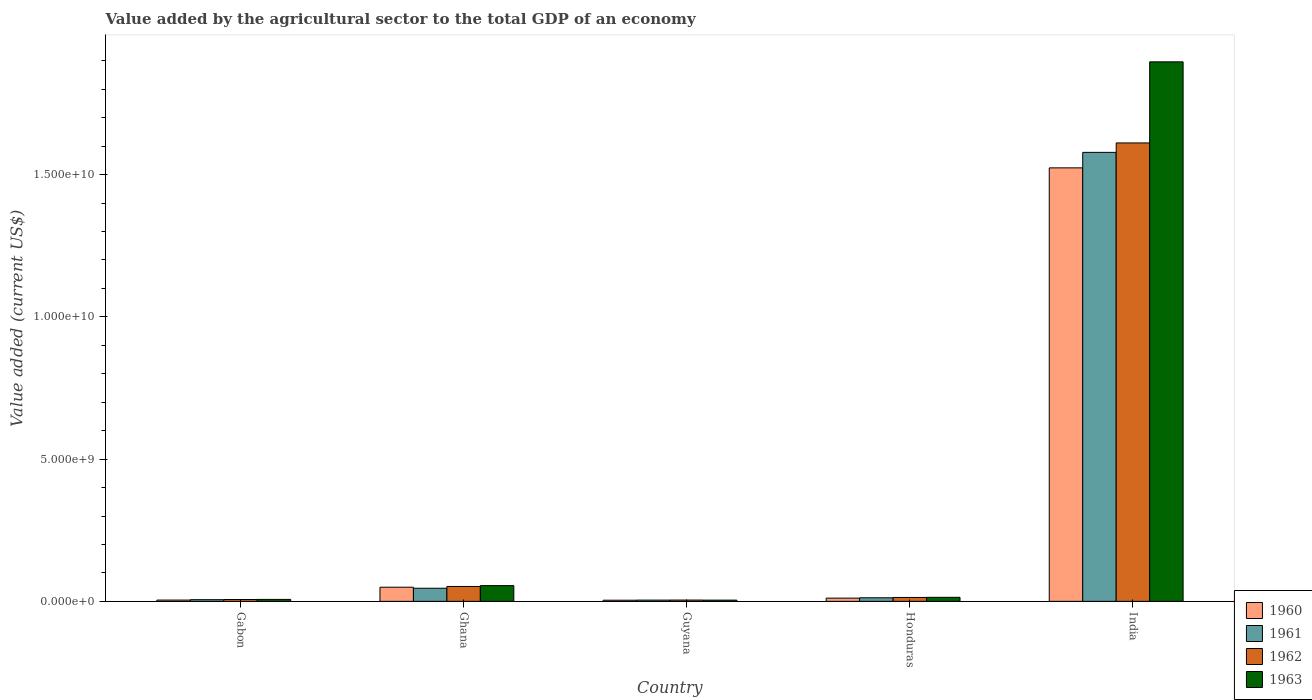How many groups of bars are there?
Offer a very short reply. 5. Are the number of bars on each tick of the X-axis equal?
Provide a short and direct response. Yes. How many bars are there on the 4th tick from the left?
Keep it short and to the point. 4. In how many cases, is the number of bars for a given country not equal to the number of legend labels?
Offer a terse response. 0. What is the value added by the agricultural sector to the total GDP in 1962 in Ghana?
Provide a succinct answer. 5.24e+08. Across all countries, what is the maximum value added by the agricultural sector to the total GDP in 1963?
Make the answer very short. 1.90e+1. Across all countries, what is the minimum value added by the agricultural sector to the total GDP in 1962?
Ensure brevity in your answer.  4.57e+07. In which country was the value added by the agricultural sector to the total GDP in 1962 maximum?
Make the answer very short. India. In which country was the value added by the agricultural sector to the total GDP in 1963 minimum?
Make the answer very short. Guyana. What is the total value added by the agricultural sector to the total GDP in 1962 in the graph?
Provide a short and direct response. 1.69e+1. What is the difference between the value added by the agricultural sector to the total GDP in 1961 in Ghana and that in Honduras?
Ensure brevity in your answer.  3.35e+08. What is the difference between the value added by the agricultural sector to the total GDP in 1961 in Ghana and the value added by the agricultural sector to the total GDP in 1962 in Honduras?
Provide a succinct answer. 3.24e+08. What is the average value added by the agricultural sector to the total GDP in 1963 per country?
Give a very brief answer. 3.95e+09. What is the difference between the value added by the agricultural sector to the total GDP of/in 1962 and value added by the agricultural sector to the total GDP of/in 1963 in India?
Keep it short and to the point. -2.85e+09. In how many countries, is the value added by the agricultural sector to the total GDP in 1961 greater than 16000000000 US$?
Ensure brevity in your answer.  0. What is the ratio of the value added by the agricultural sector to the total GDP in 1960 in Ghana to that in India?
Give a very brief answer. 0.03. What is the difference between the highest and the second highest value added by the agricultural sector to the total GDP in 1961?
Provide a short and direct response. -1.57e+1. What is the difference between the highest and the lowest value added by the agricultural sector to the total GDP in 1960?
Make the answer very short. 1.52e+1. Is the sum of the value added by the agricultural sector to the total GDP in 1961 in Gabon and Honduras greater than the maximum value added by the agricultural sector to the total GDP in 1960 across all countries?
Offer a very short reply. No. Is it the case that in every country, the sum of the value added by the agricultural sector to the total GDP in 1963 and value added by the agricultural sector to the total GDP in 1962 is greater than the sum of value added by the agricultural sector to the total GDP in 1960 and value added by the agricultural sector to the total GDP in 1961?
Offer a very short reply. No. Is it the case that in every country, the sum of the value added by the agricultural sector to the total GDP in 1963 and value added by the agricultural sector to the total GDP in 1960 is greater than the value added by the agricultural sector to the total GDP in 1961?
Keep it short and to the point. Yes. How many countries are there in the graph?
Keep it short and to the point. 5. What is the difference between two consecutive major ticks on the Y-axis?
Your answer should be very brief. 5.00e+09. Are the values on the major ticks of Y-axis written in scientific E-notation?
Make the answer very short. Yes. Does the graph contain any zero values?
Your answer should be compact. No. Does the graph contain grids?
Make the answer very short. No. Where does the legend appear in the graph?
Make the answer very short. Bottom right. What is the title of the graph?
Provide a short and direct response. Value added by the agricultural sector to the total GDP of an economy. Does "1973" appear as one of the legend labels in the graph?
Provide a succinct answer. No. What is the label or title of the X-axis?
Offer a very short reply. Country. What is the label or title of the Y-axis?
Keep it short and to the point. Value added (current US$). What is the Value added (current US$) in 1960 in Gabon?
Make the answer very short. 4.55e+07. What is the Value added (current US$) of 1961 in Gabon?
Offer a very short reply. 5.90e+07. What is the Value added (current US$) in 1962 in Gabon?
Give a very brief answer. 6.56e+07. What is the Value added (current US$) of 1963 in Gabon?
Your answer should be very brief. 6.81e+07. What is the Value added (current US$) of 1960 in Ghana?
Your answer should be very brief. 4.97e+08. What is the Value added (current US$) in 1961 in Ghana?
Provide a short and direct response. 4.61e+08. What is the Value added (current US$) in 1962 in Ghana?
Keep it short and to the point. 5.24e+08. What is the Value added (current US$) in 1963 in Ghana?
Keep it short and to the point. 5.53e+08. What is the Value added (current US$) in 1960 in Guyana?
Give a very brief answer. 4.01e+07. What is the Value added (current US$) in 1961 in Guyana?
Your response must be concise. 4.43e+07. What is the Value added (current US$) in 1962 in Guyana?
Ensure brevity in your answer.  4.57e+07. What is the Value added (current US$) of 1963 in Guyana?
Your answer should be compact. 4.30e+07. What is the Value added (current US$) in 1960 in Honduras?
Offer a very short reply. 1.14e+08. What is the Value added (current US$) of 1961 in Honduras?
Provide a succinct answer. 1.26e+08. What is the Value added (current US$) of 1962 in Honduras?
Your answer should be very brief. 1.37e+08. What is the Value added (current US$) in 1963 in Honduras?
Give a very brief answer. 1.41e+08. What is the Value added (current US$) in 1960 in India?
Provide a short and direct response. 1.52e+1. What is the Value added (current US$) in 1961 in India?
Ensure brevity in your answer.  1.58e+1. What is the Value added (current US$) in 1962 in India?
Offer a very short reply. 1.61e+1. What is the Value added (current US$) of 1963 in India?
Your answer should be very brief. 1.90e+1. Across all countries, what is the maximum Value added (current US$) of 1960?
Your response must be concise. 1.52e+1. Across all countries, what is the maximum Value added (current US$) of 1961?
Your answer should be very brief. 1.58e+1. Across all countries, what is the maximum Value added (current US$) of 1962?
Provide a short and direct response. 1.61e+1. Across all countries, what is the maximum Value added (current US$) of 1963?
Your answer should be very brief. 1.90e+1. Across all countries, what is the minimum Value added (current US$) in 1960?
Keep it short and to the point. 4.01e+07. Across all countries, what is the minimum Value added (current US$) of 1961?
Your response must be concise. 4.43e+07. Across all countries, what is the minimum Value added (current US$) in 1962?
Provide a short and direct response. 4.57e+07. Across all countries, what is the minimum Value added (current US$) of 1963?
Keep it short and to the point. 4.30e+07. What is the total Value added (current US$) in 1960 in the graph?
Offer a terse response. 1.59e+1. What is the total Value added (current US$) in 1961 in the graph?
Make the answer very short. 1.65e+1. What is the total Value added (current US$) in 1962 in the graph?
Offer a terse response. 1.69e+1. What is the total Value added (current US$) in 1963 in the graph?
Your answer should be very brief. 1.98e+1. What is the difference between the Value added (current US$) in 1960 in Gabon and that in Ghana?
Your answer should be compact. -4.52e+08. What is the difference between the Value added (current US$) of 1961 in Gabon and that in Ghana?
Keep it short and to the point. -4.02e+08. What is the difference between the Value added (current US$) in 1962 in Gabon and that in Ghana?
Provide a short and direct response. -4.58e+08. What is the difference between the Value added (current US$) of 1963 in Gabon and that in Ghana?
Your response must be concise. -4.85e+08. What is the difference between the Value added (current US$) in 1960 in Gabon and that in Guyana?
Keep it short and to the point. 5.40e+06. What is the difference between the Value added (current US$) of 1961 in Gabon and that in Guyana?
Provide a succinct answer. 1.47e+07. What is the difference between the Value added (current US$) of 1962 in Gabon and that in Guyana?
Provide a succinct answer. 1.99e+07. What is the difference between the Value added (current US$) of 1963 in Gabon and that in Guyana?
Make the answer very short. 2.51e+07. What is the difference between the Value added (current US$) of 1960 in Gabon and that in Honduras?
Your response must be concise. -6.80e+07. What is the difference between the Value added (current US$) in 1961 in Gabon and that in Honduras?
Your answer should be very brief. -6.66e+07. What is the difference between the Value added (current US$) in 1962 in Gabon and that in Honduras?
Your answer should be compact. -7.17e+07. What is the difference between the Value added (current US$) of 1963 in Gabon and that in Honduras?
Make the answer very short. -7.30e+07. What is the difference between the Value added (current US$) in 1960 in Gabon and that in India?
Give a very brief answer. -1.52e+1. What is the difference between the Value added (current US$) in 1961 in Gabon and that in India?
Provide a short and direct response. -1.57e+1. What is the difference between the Value added (current US$) in 1962 in Gabon and that in India?
Keep it short and to the point. -1.60e+1. What is the difference between the Value added (current US$) of 1963 in Gabon and that in India?
Your response must be concise. -1.89e+1. What is the difference between the Value added (current US$) in 1960 in Ghana and that in Guyana?
Give a very brief answer. 4.57e+08. What is the difference between the Value added (current US$) in 1961 in Ghana and that in Guyana?
Offer a terse response. 4.17e+08. What is the difference between the Value added (current US$) in 1962 in Ghana and that in Guyana?
Provide a succinct answer. 4.78e+08. What is the difference between the Value added (current US$) in 1963 in Ghana and that in Guyana?
Your response must be concise. 5.10e+08. What is the difference between the Value added (current US$) of 1960 in Ghana and that in Honduras?
Give a very brief answer. 3.84e+08. What is the difference between the Value added (current US$) in 1961 in Ghana and that in Honduras?
Offer a terse response. 3.35e+08. What is the difference between the Value added (current US$) in 1962 in Ghana and that in Honduras?
Your answer should be compact. 3.87e+08. What is the difference between the Value added (current US$) in 1963 in Ghana and that in Honduras?
Give a very brief answer. 4.12e+08. What is the difference between the Value added (current US$) of 1960 in Ghana and that in India?
Offer a very short reply. -1.47e+1. What is the difference between the Value added (current US$) of 1961 in Ghana and that in India?
Ensure brevity in your answer.  -1.53e+1. What is the difference between the Value added (current US$) in 1962 in Ghana and that in India?
Provide a short and direct response. -1.56e+1. What is the difference between the Value added (current US$) in 1963 in Ghana and that in India?
Offer a terse response. -1.84e+1. What is the difference between the Value added (current US$) of 1960 in Guyana and that in Honduras?
Ensure brevity in your answer.  -7.34e+07. What is the difference between the Value added (current US$) in 1961 in Guyana and that in Honduras?
Offer a terse response. -8.13e+07. What is the difference between the Value added (current US$) in 1962 in Guyana and that in Honduras?
Ensure brevity in your answer.  -9.15e+07. What is the difference between the Value added (current US$) in 1963 in Guyana and that in Honduras?
Ensure brevity in your answer.  -9.82e+07. What is the difference between the Value added (current US$) of 1960 in Guyana and that in India?
Keep it short and to the point. -1.52e+1. What is the difference between the Value added (current US$) in 1961 in Guyana and that in India?
Provide a succinct answer. -1.57e+1. What is the difference between the Value added (current US$) of 1962 in Guyana and that in India?
Ensure brevity in your answer.  -1.61e+1. What is the difference between the Value added (current US$) in 1963 in Guyana and that in India?
Your answer should be very brief. -1.89e+1. What is the difference between the Value added (current US$) in 1960 in Honduras and that in India?
Offer a very short reply. -1.51e+1. What is the difference between the Value added (current US$) in 1961 in Honduras and that in India?
Your answer should be compact. -1.57e+1. What is the difference between the Value added (current US$) of 1962 in Honduras and that in India?
Provide a short and direct response. -1.60e+1. What is the difference between the Value added (current US$) of 1963 in Honduras and that in India?
Your answer should be very brief. -1.88e+1. What is the difference between the Value added (current US$) in 1960 in Gabon and the Value added (current US$) in 1961 in Ghana?
Your response must be concise. -4.15e+08. What is the difference between the Value added (current US$) of 1960 in Gabon and the Value added (current US$) of 1962 in Ghana?
Provide a short and direct response. -4.78e+08. What is the difference between the Value added (current US$) of 1960 in Gabon and the Value added (current US$) of 1963 in Ghana?
Offer a terse response. -5.08e+08. What is the difference between the Value added (current US$) of 1961 in Gabon and the Value added (current US$) of 1962 in Ghana?
Offer a terse response. -4.65e+08. What is the difference between the Value added (current US$) in 1961 in Gabon and the Value added (current US$) in 1963 in Ghana?
Give a very brief answer. -4.94e+08. What is the difference between the Value added (current US$) in 1962 in Gabon and the Value added (current US$) in 1963 in Ghana?
Offer a terse response. -4.88e+08. What is the difference between the Value added (current US$) in 1960 in Gabon and the Value added (current US$) in 1961 in Guyana?
Make the answer very short. 1.20e+06. What is the difference between the Value added (current US$) of 1960 in Gabon and the Value added (current US$) of 1962 in Guyana?
Ensure brevity in your answer.  -1.99e+05. What is the difference between the Value added (current US$) in 1960 in Gabon and the Value added (current US$) in 1963 in Guyana?
Make the answer very short. 2.54e+06. What is the difference between the Value added (current US$) in 1961 in Gabon and the Value added (current US$) in 1962 in Guyana?
Make the answer very short. 1.33e+07. What is the difference between the Value added (current US$) of 1961 in Gabon and the Value added (current US$) of 1963 in Guyana?
Give a very brief answer. 1.60e+07. What is the difference between the Value added (current US$) of 1962 in Gabon and the Value added (current US$) of 1963 in Guyana?
Give a very brief answer. 2.26e+07. What is the difference between the Value added (current US$) in 1960 in Gabon and the Value added (current US$) in 1961 in Honduras?
Keep it short and to the point. -8.01e+07. What is the difference between the Value added (current US$) in 1960 in Gabon and the Value added (current US$) in 1962 in Honduras?
Offer a very short reply. -9.17e+07. What is the difference between the Value added (current US$) of 1960 in Gabon and the Value added (current US$) of 1963 in Honduras?
Offer a terse response. -9.56e+07. What is the difference between the Value added (current US$) of 1961 in Gabon and the Value added (current US$) of 1962 in Honduras?
Provide a succinct answer. -7.82e+07. What is the difference between the Value added (current US$) of 1961 in Gabon and the Value added (current US$) of 1963 in Honduras?
Make the answer very short. -8.21e+07. What is the difference between the Value added (current US$) in 1962 in Gabon and the Value added (current US$) in 1963 in Honduras?
Provide a short and direct response. -7.56e+07. What is the difference between the Value added (current US$) of 1960 in Gabon and the Value added (current US$) of 1961 in India?
Provide a succinct answer. -1.57e+1. What is the difference between the Value added (current US$) in 1960 in Gabon and the Value added (current US$) in 1962 in India?
Give a very brief answer. -1.61e+1. What is the difference between the Value added (current US$) in 1960 in Gabon and the Value added (current US$) in 1963 in India?
Offer a very short reply. -1.89e+1. What is the difference between the Value added (current US$) in 1961 in Gabon and the Value added (current US$) in 1962 in India?
Keep it short and to the point. -1.61e+1. What is the difference between the Value added (current US$) of 1961 in Gabon and the Value added (current US$) of 1963 in India?
Your answer should be very brief. -1.89e+1. What is the difference between the Value added (current US$) in 1962 in Gabon and the Value added (current US$) in 1963 in India?
Provide a short and direct response. -1.89e+1. What is the difference between the Value added (current US$) of 1960 in Ghana and the Value added (current US$) of 1961 in Guyana?
Offer a terse response. 4.53e+08. What is the difference between the Value added (current US$) in 1960 in Ghana and the Value added (current US$) in 1962 in Guyana?
Give a very brief answer. 4.52e+08. What is the difference between the Value added (current US$) in 1960 in Ghana and the Value added (current US$) in 1963 in Guyana?
Your answer should be very brief. 4.54e+08. What is the difference between the Value added (current US$) of 1961 in Ghana and the Value added (current US$) of 1962 in Guyana?
Your response must be concise. 4.15e+08. What is the difference between the Value added (current US$) in 1961 in Ghana and the Value added (current US$) in 1963 in Guyana?
Your answer should be very brief. 4.18e+08. What is the difference between the Value added (current US$) in 1962 in Ghana and the Value added (current US$) in 1963 in Guyana?
Give a very brief answer. 4.81e+08. What is the difference between the Value added (current US$) of 1960 in Ghana and the Value added (current US$) of 1961 in Honduras?
Your answer should be compact. 3.72e+08. What is the difference between the Value added (current US$) of 1960 in Ghana and the Value added (current US$) of 1962 in Honduras?
Ensure brevity in your answer.  3.60e+08. What is the difference between the Value added (current US$) in 1960 in Ghana and the Value added (current US$) in 1963 in Honduras?
Provide a succinct answer. 3.56e+08. What is the difference between the Value added (current US$) in 1961 in Ghana and the Value added (current US$) in 1962 in Honduras?
Offer a very short reply. 3.24e+08. What is the difference between the Value added (current US$) of 1961 in Ghana and the Value added (current US$) of 1963 in Honduras?
Your answer should be compact. 3.20e+08. What is the difference between the Value added (current US$) in 1962 in Ghana and the Value added (current US$) in 1963 in Honduras?
Offer a very short reply. 3.83e+08. What is the difference between the Value added (current US$) of 1960 in Ghana and the Value added (current US$) of 1961 in India?
Give a very brief answer. -1.53e+1. What is the difference between the Value added (current US$) of 1960 in Ghana and the Value added (current US$) of 1962 in India?
Your answer should be very brief. -1.56e+1. What is the difference between the Value added (current US$) in 1960 in Ghana and the Value added (current US$) in 1963 in India?
Your answer should be compact. -1.85e+1. What is the difference between the Value added (current US$) of 1961 in Ghana and the Value added (current US$) of 1962 in India?
Make the answer very short. -1.57e+1. What is the difference between the Value added (current US$) of 1961 in Ghana and the Value added (current US$) of 1963 in India?
Ensure brevity in your answer.  -1.85e+1. What is the difference between the Value added (current US$) of 1962 in Ghana and the Value added (current US$) of 1963 in India?
Your answer should be compact. -1.84e+1. What is the difference between the Value added (current US$) of 1960 in Guyana and the Value added (current US$) of 1961 in Honduras?
Provide a succinct answer. -8.55e+07. What is the difference between the Value added (current US$) of 1960 in Guyana and the Value added (current US$) of 1962 in Honduras?
Give a very brief answer. -9.71e+07. What is the difference between the Value added (current US$) of 1960 in Guyana and the Value added (current US$) of 1963 in Honduras?
Give a very brief answer. -1.01e+08. What is the difference between the Value added (current US$) of 1961 in Guyana and the Value added (current US$) of 1962 in Honduras?
Give a very brief answer. -9.29e+07. What is the difference between the Value added (current US$) in 1961 in Guyana and the Value added (current US$) in 1963 in Honduras?
Make the answer very short. -9.68e+07. What is the difference between the Value added (current US$) in 1962 in Guyana and the Value added (current US$) in 1963 in Honduras?
Provide a succinct answer. -9.54e+07. What is the difference between the Value added (current US$) of 1960 in Guyana and the Value added (current US$) of 1961 in India?
Keep it short and to the point. -1.57e+1. What is the difference between the Value added (current US$) of 1960 in Guyana and the Value added (current US$) of 1962 in India?
Ensure brevity in your answer.  -1.61e+1. What is the difference between the Value added (current US$) in 1960 in Guyana and the Value added (current US$) in 1963 in India?
Your answer should be compact. -1.89e+1. What is the difference between the Value added (current US$) of 1961 in Guyana and the Value added (current US$) of 1962 in India?
Provide a succinct answer. -1.61e+1. What is the difference between the Value added (current US$) in 1961 in Guyana and the Value added (current US$) in 1963 in India?
Your answer should be compact. -1.89e+1. What is the difference between the Value added (current US$) of 1962 in Guyana and the Value added (current US$) of 1963 in India?
Keep it short and to the point. -1.89e+1. What is the difference between the Value added (current US$) of 1960 in Honduras and the Value added (current US$) of 1961 in India?
Offer a terse response. -1.57e+1. What is the difference between the Value added (current US$) in 1960 in Honduras and the Value added (current US$) in 1962 in India?
Your response must be concise. -1.60e+1. What is the difference between the Value added (current US$) of 1960 in Honduras and the Value added (current US$) of 1963 in India?
Ensure brevity in your answer.  -1.89e+1. What is the difference between the Value added (current US$) of 1961 in Honduras and the Value added (current US$) of 1962 in India?
Your answer should be very brief. -1.60e+1. What is the difference between the Value added (current US$) in 1961 in Honduras and the Value added (current US$) in 1963 in India?
Provide a short and direct response. -1.88e+1. What is the difference between the Value added (current US$) of 1962 in Honduras and the Value added (current US$) of 1963 in India?
Give a very brief answer. -1.88e+1. What is the average Value added (current US$) in 1960 per country?
Provide a succinct answer. 3.19e+09. What is the average Value added (current US$) of 1961 per country?
Ensure brevity in your answer.  3.29e+09. What is the average Value added (current US$) in 1962 per country?
Offer a very short reply. 3.38e+09. What is the average Value added (current US$) of 1963 per country?
Your answer should be compact. 3.95e+09. What is the difference between the Value added (current US$) in 1960 and Value added (current US$) in 1961 in Gabon?
Provide a short and direct response. -1.35e+07. What is the difference between the Value added (current US$) in 1960 and Value added (current US$) in 1962 in Gabon?
Your answer should be compact. -2.01e+07. What is the difference between the Value added (current US$) of 1960 and Value added (current US$) of 1963 in Gabon?
Your answer should be compact. -2.26e+07. What is the difference between the Value added (current US$) of 1961 and Value added (current US$) of 1962 in Gabon?
Your answer should be very brief. -6.57e+06. What is the difference between the Value added (current US$) of 1961 and Value added (current US$) of 1963 in Gabon?
Provide a succinct answer. -9.07e+06. What is the difference between the Value added (current US$) of 1962 and Value added (current US$) of 1963 in Gabon?
Provide a short and direct response. -2.50e+06. What is the difference between the Value added (current US$) in 1960 and Value added (current US$) in 1961 in Ghana?
Make the answer very short. 3.64e+07. What is the difference between the Value added (current US$) of 1960 and Value added (current US$) of 1962 in Ghana?
Ensure brevity in your answer.  -2.66e+07. What is the difference between the Value added (current US$) in 1960 and Value added (current US$) in 1963 in Ghana?
Offer a terse response. -5.60e+07. What is the difference between the Value added (current US$) in 1961 and Value added (current US$) in 1962 in Ghana?
Your response must be concise. -6.30e+07. What is the difference between the Value added (current US$) of 1961 and Value added (current US$) of 1963 in Ghana?
Offer a terse response. -9.24e+07. What is the difference between the Value added (current US$) of 1962 and Value added (current US$) of 1963 in Ghana?
Your response must be concise. -2.94e+07. What is the difference between the Value added (current US$) in 1960 and Value added (current US$) in 1961 in Guyana?
Provide a short and direct response. -4.20e+06. What is the difference between the Value added (current US$) in 1960 and Value added (current US$) in 1962 in Guyana?
Keep it short and to the point. -5.60e+06. What is the difference between the Value added (current US$) of 1960 and Value added (current US$) of 1963 in Guyana?
Offer a terse response. -2.86e+06. What is the difference between the Value added (current US$) of 1961 and Value added (current US$) of 1962 in Guyana?
Offer a very short reply. -1.40e+06. What is the difference between the Value added (current US$) of 1961 and Value added (current US$) of 1963 in Guyana?
Keep it short and to the point. 1.34e+06. What is the difference between the Value added (current US$) of 1962 and Value added (current US$) of 1963 in Guyana?
Offer a very short reply. 2.74e+06. What is the difference between the Value added (current US$) of 1960 and Value added (current US$) of 1961 in Honduras?
Give a very brief answer. -1.21e+07. What is the difference between the Value added (current US$) of 1960 and Value added (current US$) of 1962 in Honduras?
Your response must be concise. -2.38e+07. What is the difference between the Value added (current US$) of 1960 and Value added (current US$) of 1963 in Honduras?
Provide a succinct answer. -2.76e+07. What is the difference between the Value added (current US$) in 1961 and Value added (current US$) in 1962 in Honduras?
Offer a terse response. -1.16e+07. What is the difference between the Value added (current US$) in 1961 and Value added (current US$) in 1963 in Honduras?
Your answer should be compact. -1.56e+07. What is the difference between the Value added (current US$) of 1962 and Value added (current US$) of 1963 in Honduras?
Your answer should be very brief. -3.90e+06. What is the difference between the Value added (current US$) in 1960 and Value added (current US$) in 1961 in India?
Make the answer very short. -5.45e+08. What is the difference between the Value added (current US$) in 1960 and Value added (current US$) in 1962 in India?
Provide a short and direct response. -8.76e+08. What is the difference between the Value added (current US$) in 1960 and Value added (current US$) in 1963 in India?
Your answer should be very brief. -3.73e+09. What is the difference between the Value added (current US$) in 1961 and Value added (current US$) in 1962 in India?
Keep it short and to the point. -3.32e+08. What is the difference between the Value added (current US$) in 1961 and Value added (current US$) in 1963 in India?
Make the answer very short. -3.18e+09. What is the difference between the Value added (current US$) of 1962 and Value added (current US$) of 1963 in India?
Make the answer very short. -2.85e+09. What is the ratio of the Value added (current US$) in 1960 in Gabon to that in Ghana?
Provide a succinct answer. 0.09. What is the ratio of the Value added (current US$) of 1961 in Gabon to that in Ghana?
Your answer should be compact. 0.13. What is the ratio of the Value added (current US$) in 1962 in Gabon to that in Ghana?
Your response must be concise. 0.13. What is the ratio of the Value added (current US$) in 1963 in Gabon to that in Ghana?
Make the answer very short. 0.12. What is the ratio of the Value added (current US$) of 1960 in Gabon to that in Guyana?
Your response must be concise. 1.13. What is the ratio of the Value added (current US$) of 1961 in Gabon to that in Guyana?
Make the answer very short. 1.33. What is the ratio of the Value added (current US$) of 1962 in Gabon to that in Guyana?
Offer a very short reply. 1.43. What is the ratio of the Value added (current US$) in 1963 in Gabon to that in Guyana?
Provide a succinct answer. 1.58. What is the ratio of the Value added (current US$) in 1960 in Gabon to that in Honduras?
Offer a terse response. 0.4. What is the ratio of the Value added (current US$) in 1961 in Gabon to that in Honduras?
Give a very brief answer. 0.47. What is the ratio of the Value added (current US$) in 1962 in Gabon to that in Honduras?
Offer a terse response. 0.48. What is the ratio of the Value added (current US$) in 1963 in Gabon to that in Honduras?
Provide a succinct answer. 0.48. What is the ratio of the Value added (current US$) in 1960 in Gabon to that in India?
Your response must be concise. 0. What is the ratio of the Value added (current US$) in 1961 in Gabon to that in India?
Keep it short and to the point. 0. What is the ratio of the Value added (current US$) of 1962 in Gabon to that in India?
Provide a succinct answer. 0. What is the ratio of the Value added (current US$) in 1963 in Gabon to that in India?
Your answer should be very brief. 0. What is the ratio of the Value added (current US$) of 1960 in Ghana to that in Guyana?
Ensure brevity in your answer.  12.39. What is the ratio of the Value added (current US$) of 1961 in Ghana to that in Guyana?
Keep it short and to the point. 10.39. What is the ratio of the Value added (current US$) of 1962 in Ghana to that in Guyana?
Your answer should be compact. 11.45. What is the ratio of the Value added (current US$) of 1963 in Ghana to that in Guyana?
Offer a very short reply. 12.87. What is the ratio of the Value added (current US$) of 1960 in Ghana to that in Honduras?
Make the answer very short. 4.38. What is the ratio of the Value added (current US$) in 1961 in Ghana to that in Honduras?
Keep it short and to the point. 3.67. What is the ratio of the Value added (current US$) in 1962 in Ghana to that in Honduras?
Your response must be concise. 3.82. What is the ratio of the Value added (current US$) in 1963 in Ghana to that in Honduras?
Your response must be concise. 3.92. What is the ratio of the Value added (current US$) in 1960 in Ghana to that in India?
Provide a succinct answer. 0.03. What is the ratio of the Value added (current US$) in 1961 in Ghana to that in India?
Provide a succinct answer. 0.03. What is the ratio of the Value added (current US$) in 1962 in Ghana to that in India?
Keep it short and to the point. 0.03. What is the ratio of the Value added (current US$) of 1963 in Ghana to that in India?
Keep it short and to the point. 0.03. What is the ratio of the Value added (current US$) in 1960 in Guyana to that in Honduras?
Offer a terse response. 0.35. What is the ratio of the Value added (current US$) in 1961 in Guyana to that in Honduras?
Your answer should be very brief. 0.35. What is the ratio of the Value added (current US$) of 1962 in Guyana to that in Honduras?
Offer a terse response. 0.33. What is the ratio of the Value added (current US$) in 1963 in Guyana to that in Honduras?
Offer a very short reply. 0.3. What is the ratio of the Value added (current US$) of 1960 in Guyana to that in India?
Offer a terse response. 0. What is the ratio of the Value added (current US$) of 1961 in Guyana to that in India?
Your answer should be compact. 0. What is the ratio of the Value added (current US$) of 1962 in Guyana to that in India?
Make the answer very short. 0. What is the ratio of the Value added (current US$) in 1963 in Guyana to that in India?
Offer a very short reply. 0. What is the ratio of the Value added (current US$) of 1960 in Honduras to that in India?
Your answer should be compact. 0.01. What is the ratio of the Value added (current US$) in 1961 in Honduras to that in India?
Make the answer very short. 0.01. What is the ratio of the Value added (current US$) of 1962 in Honduras to that in India?
Ensure brevity in your answer.  0.01. What is the ratio of the Value added (current US$) of 1963 in Honduras to that in India?
Offer a terse response. 0.01. What is the difference between the highest and the second highest Value added (current US$) of 1960?
Give a very brief answer. 1.47e+1. What is the difference between the highest and the second highest Value added (current US$) of 1961?
Give a very brief answer. 1.53e+1. What is the difference between the highest and the second highest Value added (current US$) of 1962?
Provide a short and direct response. 1.56e+1. What is the difference between the highest and the second highest Value added (current US$) in 1963?
Give a very brief answer. 1.84e+1. What is the difference between the highest and the lowest Value added (current US$) of 1960?
Make the answer very short. 1.52e+1. What is the difference between the highest and the lowest Value added (current US$) of 1961?
Ensure brevity in your answer.  1.57e+1. What is the difference between the highest and the lowest Value added (current US$) of 1962?
Your response must be concise. 1.61e+1. What is the difference between the highest and the lowest Value added (current US$) in 1963?
Keep it short and to the point. 1.89e+1. 